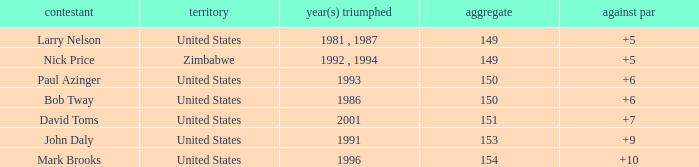What is the total for 1986 with a to par higher than 6? 0.0. 